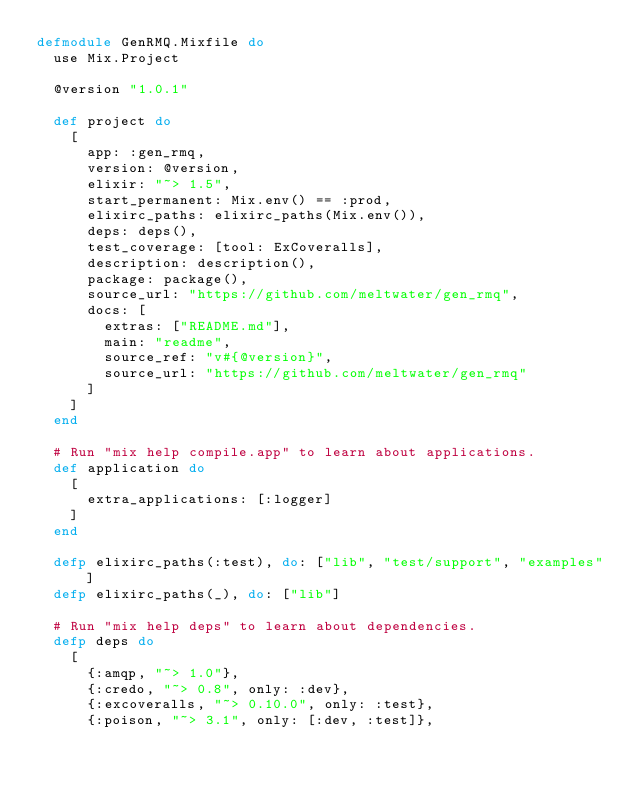<code> <loc_0><loc_0><loc_500><loc_500><_Elixir_>defmodule GenRMQ.Mixfile do
  use Mix.Project

  @version "1.0.1"

  def project do
    [
      app: :gen_rmq,
      version: @version,
      elixir: "~> 1.5",
      start_permanent: Mix.env() == :prod,
      elixirc_paths: elixirc_paths(Mix.env()),
      deps: deps(),
      test_coverage: [tool: ExCoveralls],
      description: description(),
      package: package(),
      source_url: "https://github.com/meltwater/gen_rmq",
      docs: [
        extras: ["README.md"],
        main: "readme",
        source_ref: "v#{@version}",
        source_url: "https://github.com/meltwater/gen_rmq"
      ]
    ]
  end

  # Run "mix help compile.app" to learn about applications.
  def application do
    [
      extra_applications: [:logger]
    ]
  end

  defp elixirc_paths(:test), do: ["lib", "test/support", "examples"]
  defp elixirc_paths(_), do: ["lib"]

  # Run "mix help deps" to learn about dependencies.
  defp deps do
    [
      {:amqp, "~> 1.0"},
      {:credo, "~> 0.8", only: :dev},
      {:excoveralls, "~> 0.10.0", only: :test},
      {:poison, "~> 3.1", only: [:dev, :test]},</code> 